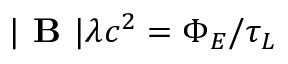Convert formula to latex. <formula><loc_0><loc_0><loc_500><loc_500>| B | \lambda c ^ { 2 } = \Phi _ { E } / \tau _ { L }</formula> 